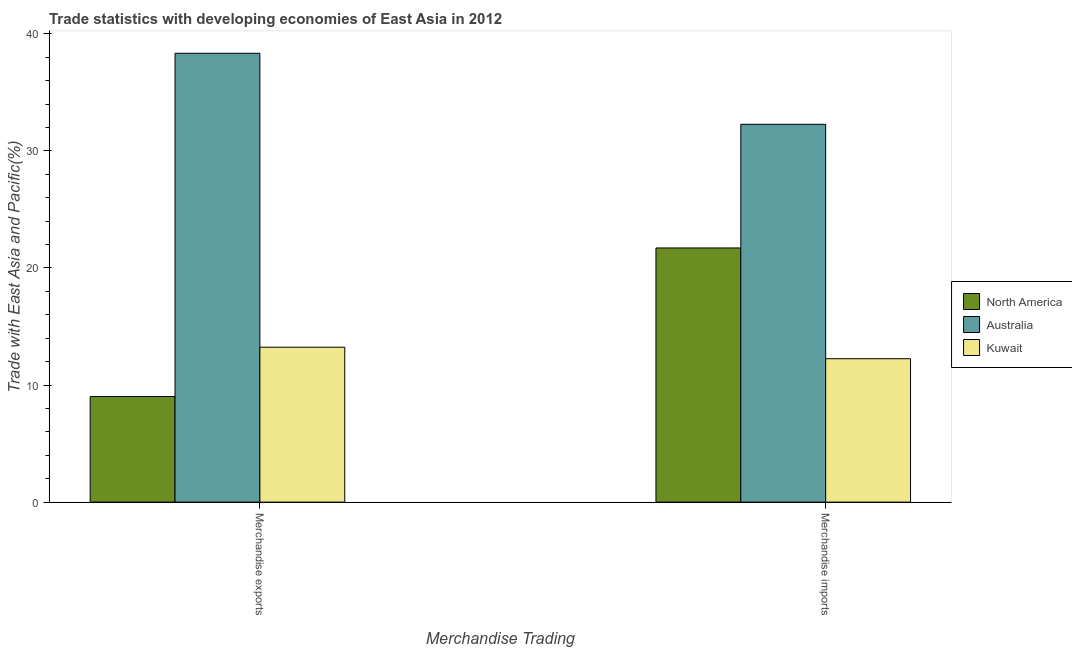How many different coloured bars are there?
Keep it short and to the point. 3. How many groups of bars are there?
Your response must be concise. 2. Are the number of bars per tick equal to the number of legend labels?
Give a very brief answer. Yes. Are the number of bars on each tick of the X-axis equal?
Keep it short and to the point. Yes. How many bars are there on the 2nd tick from the left?
Your answer should be compact. 3. What is the merchandise imports in Kuwait?
Your answer should be compact. 12.25. Across all countries, what is the maximum merchandise exports?
Your answer should be compact. 38.34. Across all countries, what is the minimum merchandise imports?
Your answer should be very brief. 12.25. In which country was the merchandise imports maximum?
Ensure brevity in your answer.  Australia. In which country was the merchandise exports minimum?
Ensure brevity in your answer.  North America. What is the total merchandise imports in the graph?
Make the answer very short. 66.22. What is the difference between the merchandise exports in Australia and that in Kuwait?
Offer a very short reply. 25.1. What is the difference between the merchandise imports in Kuwait and the merchandise exports in Australia?
Give a very brief answer. -26.09. What is the average merchandise exports per country?
Keep it short and to the point. 20.19. What is the difference between the merchandise exports and merchandise imports in North America?
Offer a very short reply. -12.69. What is the ratio of the merchandise exports in Australia to that in North America?
Provide a short and direct response. 4.25. How many countries are there in the graph?
Give a very brief answer. 3. What is the difference between two consecutive major ticks on the Y-axis?
Your response must be concise. 10. Does the graph contain grids?
Keep it short and to the point. No. Where does the legend appear in the graph?
Keep it short and to the point. Center right. What is the title of the graph?
Give a very brief answer. Trade statistics with developing economies of East Asia in 2012. What is the label or title of the X-axis?
Provide a short and direct response. Merchandise Trading. What is the label or title of the Y-axis?
Keep it short and to the point. Trade with East Asia and Pacific(%). What is the Trade with East Asia and Pacific(%) in North America in Merchandise exports?
Give a very brief answer. 9.02. What is the Trade with East Asia and Pacific(%) of Australia in Merchandise exports?
Keep it short and to the point. 38.34. What is the Trade with East Asia and Pacific(%) in Kuwait in Merchandise exports?
Keep it short and to the point. 13.23. What is the Trade with East Asia and Pacific(%) in North America in Merchandise imports?
Your answer should be compact. 21.71. What is the Trade with East Asia and Pacific(%) of Australia in Merchandise imports?
Your response must be concise. 32.27. What is the Trade with East Asia and Pacific(%) of Kuwait in Merchandise imports?
Your answer should be compact. 12.25. Across all Merchandise Trading, what is the maximum Trade with East Asia and Pacific(%) of North America?
Keep it short and to the point. 21.71. Across all Merchandise Trading, what is the maximum Trade with East Asia and Pacific(%) of Australia?
Provide a short and direct response. 38.34. Across all Merchandise Trading, what is the maximum Trade with East Asia and Pacific(%) in Kuwait?
Your answer should be compact. 13.23. Across all Merchandise Trading, what is the minimum Trade with East Asia and Pacific(%) of North America?
Offer a terse response. 9.02. Across all Merchandise Trading, what is the minimum Trade with East Asia and Pacific(%) of Australia?
Make the answer very short. 32.27. Across all Merchandise Trading, what is the minimum Trade with East Asia and Pacific(%) in Kuwait?
Your answer should be compact. 12.25. What is the total Trade with East Asia and Pacific(%) in North America in the graph?
Your response must be concise. 30.72. What is the total Trade with East Asia and Pacific(%) of Australia in the graph?
Your answer should be compact. 70.61. What is the total Trade with East Asia and Pacific(%) in Kuwait in the graph?
Your answer should be very brief. 25.48. What is the difference between the Trade with East Asia and Pacific(%) in North America in Merchandise exports and that in Merchandise imports?
Offer a very short reply. -12.69. What is the difference between the Trade with East Asia and Pacific(%) in Australia in Merchandise exports and that in Merchandise imports?
Your answer should be very brief. 6.07. What is the difference between the Trade with East Asia and Pacific(%) in Kuwait in Merchandise exports and that in Merchandise imports?
Offer a terse response. 0.98. What is the difference between the Trade with East Asia and Pacific(%) of North America in Merchandise exports and the Trade with East Asia and Pacific(%) of Australia in Merchandise imports?
Your answer should be compact. -23.25. What is the difference between the Trade with East Asia and Pacific(%) of North America in Merchandise exports and the Trade with East Asia and Pacific(%) of Kuwait in Merchandise imports?
Your answer should be compact. -3.23. What is the difference between the Trade with East Asia and Pacific(%) of Australia in Merchandise exports and the Trade with East Asia and Pacific(%) of Kuwait in Merchandise imports?
Offer a terse response. 26.09. What is the average Trade with East Asia and Pacific(%) in North America per Merchandise Trading?
Give a very brief answer. 15.36. What is the average Trade with East Asia and Pacific(%) in Australia per Merchandise Trading?
Your answer should be very brief. 35.3. What is the average Trade with East Asia and Pacific(%) of Kuwait per Merchandise Trading?
Ensure brevity in your answer.  12.74. What is the difference between the Trade with East Asia and Pacific(%) of North America and Trade with East Asia and Pacific(%) of Australia in Merchandise exports?
Your answer should be compact. -29.32. What is the difference between the Trade with East Asia and Pacific(%) in North America and Trade with East Asia and Pacific(%) in Kuwait in Merchandise exports?
Your answer should be compact. -4.22. What is the difference between the Trade with East Asia and Pacific(%) of Australia and Trade with East Asia and Pacific(%) of Kuwait in Merchandise exports?
Keep it short and to the point. 25.1. What is the difference between the Trade with East Asia and Pacific(%) in North America and Trade with East Asia and Pacific(%) in Australia in Merchandise imports?
Provide a short and direct response. -10.56. What is the difference between the Trade with East Asia and Pacific(%) of North America and Trade with East Asia and Pacific(%) of Kuwait in Merchandise imports?
Provide a succinct answer. 9.46. What is the difference between the Trade with East Asia and Pacific(%) of Australia and Trade with East Asia and Pacific(%) of Kuwait in Merchandise imports?
Your answer should be compact. 20.02. What is the ratio of the Trade with East Asia and Pacific(%) in North America in Merchandise exports to that in Merchandise imports?
Keep it short and to the point. 0.42. What is the ratio of the Trade with East Asia and Pacific(%) of Australia in Merchandise exports to that in Merchandise imports?
Provide a short and direct response. 1.19. What is the ratio of the Trade with East Asia and Pacific(%) in Kuwait in Merchandise exports to that in Merchandise imports?
Give a very brief answer. 1.08. What is the difference between the highest and the second highest Trade with East Asia and Pacific(%) in North America?
Keep it short and to the point. 12.69. What is the difference between the highest and the second highest Trade with East Asia and Pacific(%) of Australia?
Your answer should be very brief. 6.07. What is the difference between the highest and the second highest Trade with East Asia and Pacific(%) of Kuwait?
Keep it short and to the point. 0.98. What is the difference between the highest and the lowest Trade with East Asia and Pacific(%) of North America?
Your answer should be compact. 12.69. What is the difference between the highest and the lowest Trade with East Asia and Pacific(%) in Australia?
Ensure brevity in your answer.  6.07. What is the difference between the highest and the lowest Trade with East Asia and Pacific(%) in Kuwait?
Your answer should be compact. 0.98. 